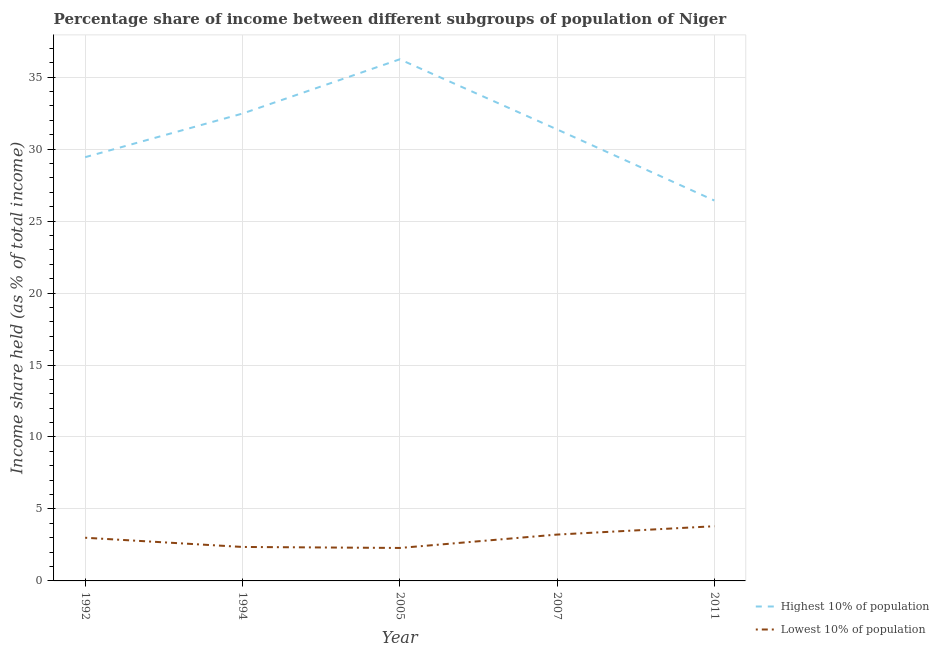Does the line corresponding to income share held by lowest 10% of the population intersect with the line corresponding to income share held by highest 10% of the population?
Your answer should be compact. No. Is the number of lines equal to the number of legend labels?
Your answer should be compact. Yes. What is the income share held by highest 10% of the population in 2005?
Your answer should be compact. 36.24. Across all years, what is the minimum income share held by lowest 10% of the population?
Your answer should be compact. 2.29. In which year was the income share held by lowest 10% of the population minimum?
Give a very brief answer. 2005. What is the total income share held by highest 10% of the population in the graph?
Provide a short and direct response. 155.95. What is the difference between the income share held by highest 10% of the population in 2007 and that in 2011?
Make the answer very short. 4.94. What is the difference between the income share held by highest 10% of the population in 2011 and the income share held by lowest 10% of the population in 2007?
Ensure brevity in your answer.  23.21. What is the average income share held by highest 10% of the population per year?
Provide a short and direct response. 31.19. In the year 2011, what is the difference between the income share held by lowest 10% of the population and income share held by highest 10% of the population?
Your answer should be compact. -22.63. In how many years, is the income share held by lowest 10% of the population greater than 29 %?
Provide a succinct answer. 0. What is the ratio of the income share held by lowest 10% of the population in 1994 to that in 2007?
Offer a terse response. 0.73. Is the income share held by highest 10% of the population in 1994 less than that in 2007?
Keep it short and to the point. No. What is the difference between the highest and the second highest income share held by highest 10% of the population?
Make the answer very short. 3.77. What is the difference between the highest and the lowest income share held by lowest 10% of the population?
Your response must be concise. 1.51. In how many years, is the income share held by highest 10% of the population greater than the average income share held by highest 10% of the population taken over all years?
Your answer should be compact. 3. Does the income share held by lowest 10% of the population monotonically increase over the years?
Give a very brief answer. No. Is the income share held by highest 10% of the population strictly greater than the income share held by lowest 10% of the population over the years?
Provide a succinct answer. Yes. How many lines are there?
Offer a very short reply. 2. How many years are there in the graph?
Ensure brevity in your answer.  5. What is the difference between two consecutive major ticks on the Y-axis?
Offer a very short reply. 5. Are the values on the major ticks of Y-axis written in scientific E-notation?
Your answer should be compact. No. Does the graph contain any zero values?
Provide a short and direct response. No. How many legend labels are there?
Your answer should be very brief. 2. How are the legend labels stacked?
Your answer should be compact. Vertical. What is the title of the graph?
Keep it short and to the point. Percentage share of income between different subgroups of population of Niger. Does "International Visitors" appear as one of the legend labels in the graph?
Give a very brief answer. No. What is the label or title of the X-axis?
Your response must be concise. Year. What is the label or title of the Y-axis?
Provide a short and direct response. Income share held (as % of total income). What is the Income share held (as % of total income) of Highest 10% of population in 1992?
Provide a short and direct response. 29.44. What is the Income share held (as % of total income) of Highest 10% of population in 1994?
Your answer should be very brief. 32.47. What is the Income share held (as % of total income) of Lowest 10% of population in 1994?
Offer a terse response. 2.36. What is the Income share held (as % of total income) in Highest 10% of population in 2005?
Offer a very short reply. 36.24. What is the Income share held (as % of total income) of Lowest 10% of population in 2005?
Offer a terse response. 2.29. What is the Income share held (as % of total income) of Highest 10% of population in 2007?
Provide a short and direct response. 31.37. What is the Income share held (as % of total income) in Lowest 10% of population in 2007?
Offer a terse response. 3.22. What is the Income share held (as % of total income) in Highest 10% of population in 2011?
Keep it short and to the point. 26.43. Across all years, what is the maximum Income share held (as % of total income) of Highest 10% of population?
Offer a very short reply. 36.24. Across all years, what is the minimum Income share held (as % of total income) in Highest 10% of population?
Offer a very short reply. 26.43. Across all years, what is the minimum Income share held (as % of total income) of Lowest 10% of population?
Make the answer very short. 2.29. What is the total Income share held (as % of total income) in Highest 10% of population in the graph?
Provide a short and direct response. 155.95. What is the total Income share held (as % of total income) in Lowest 10% of population in the graph?
Keep it short and to the point. 14.67. What is the difference between the Income share held (as % of total income) in Highest 10% of population in 1992 and that in 1994?
Ensure brevity in your answer.  -3.03. What is the difference between the Income share held (as % of total income) of Lowest 10% of population in 1992 and that in 1994?
Provide a short and direct response. 0.64. What is the difference between the Income share held (as % of total income) in Highest 10% of population in 1992 and that in 2005?
Your response must be concise. -6.8. What is the difference between the Income share held (as % of total income) of Lowest 10% of population in 1992 and that in 2005?
Your answer should be very brief. 0.71. What is the difference between the Income share held (as % of total income) of Highest 10% of population in 1992 and that in 2007?
Offer a terse response. -1.93. What is the difference between the Income share held (as % of total income) in Lowest 10% of population in 1992 and that in 2007?
Your answer should be very brief. -0.22. What is the difference between the Income share held (as % of total income) of Highest 10% of population in 1992 and that in 2011?
Keep it short and to the point. 3.01. What is the difference between the Income share held (as % of total income) in Lowest 10% of population in 1992 and that in 2011?
Give a very brief answer. -0.8. What is the difference between the Income share held (as % of total income) in Highest 10% of population in 1994 and that in 2005?
Provide a succinct answer. -3.77. What is the difference between the Income share held (as % of total income) of Lowest 10% of population in 1994 and that in 2005?
Provide a succinct answer. 0.07. What is the difference between the Income share held (as % of total income) of Lowest 10% of population in 1994 and that in 2007?
Your response must be concise. -0.86. What is the difference between the Income share held (as % of total income) in Highest 10% of population in 1994 and that in 2011?
Your answer should be very brief. 6.04. What is the difference between the Income share held (as % of total income) of Lowest 10% of population in 1994 and that in 2011?
Provide a succinct answer. -1.44. What is the difference between the Income share held (as % of total income) of Highest 10% of population in 2005 and that in 2007?
Provide a short and direct response. 4.87. What is the difference between the Income share held (as % of total income) in Lowest 10% of population in 2005 and that in 2007?
Give a very brief answer. -0.93. What is the difference between the Income share held (as % of total income) of Highest 10% of population in 2005 and that in 2011?
Your answer should be very brief. 9.81. What is the difference between the Income share held (as % of total income) in Lowest 10% of population in 2005 and that in 2011?
Offer a terse response. -1.51. What is the difference between the Income share held (as % of total income) in Highest 10% of population in 2007 and that in 2011?
Offer a very short reply. 4.94. What is the difference between the Income share held (as % of total income) in Lowest 10% of population in 2007 and that in 2011?
Your answer should be compact. -0.58. What is the difference between the Income share held (as % of total income) of Highest 10% of population in 1992 and the Income share held (as % of total income) of Lowest 10% of population in 1994?
Keep it short and to the point. 27.08. What is the difference between the Income share held (as % of total income) in Highest 10% of population in 1992 and the Income share held (as % of total income) in Lowest 10% of population in 2005?
Ensure brevity in your answer.  27.15. What is the difference between the Income share held (as % of total income) of Highest 10% of population in 1992 and the Income share held (as % of total income) of Lowest 10% of population in 2007?
Offer a terse response. 26.22. What is the difference between the Income share held (as % of total income) of Highest 10% of population in 1992 and the Income share held (as % of total income) of Lowest 10% of population in 2011?
Your answer should be compact. 25.64. What is the difference between the Income share held (as % of total income) of Highest 10% of population in 1994 and the Income share held (as % of total income) of Lowest 10% of population in 2005?
Provide a short and direct response. 30.18. What is the difference between the Income share held (as % of total income) of Highest 10% of population in 1994 and the Income share held (as % of total income) of Lowest 10% of population in 2007?
Your answer should be compact. 29.25. What is the difference between the Income share held (as % of total income) in Highest 10% of population in 1994 and the Income share held (as % of total income) in Lowest 10% of population in 2011?
Ensure brevity in your answer.  28.67. What is the difference between the Income share held (as % of total income) in Highest 10% of population in 2005 and the Income share held (as % of total income) in Lowest 10% of population in 2007?
Provide a succinct answer. 33.02. What is the difference between the Income share held (as % of total income) of Highest 10% of population in 2005 and the Income share held (as % of total income) of Lowest 10% of population in 2011?
Ensure brevity in your answer.  32.44. What is the difference between the Income share held (as % of total income) of Highest 10% of population in 2007 and the Income share held (as % of total income) of Lowest 10% of population in 2011?
Your response must be concise. 27.57. What is the average Income share held (as % of total income) in Highest 10% of population per year?
Keep it short and to the point. 31.19. What is the average Income share held (as % of total income) in Lowest 10% of population per year?
Give a very brief answer. 2.93. In the year 1992, what is the difference between the Income share held (as % of total income) of Highest 10% of population and Income share held (as % of total income) of Lowest 10% of population?
Keep it short and to the point. 26.44. In the year 1994, what is the difference between the Income share held (as % of total income) in Highest 10% of population and Income share held (as % of total income) in Lowest 10% of population?
Offer a terse response. 30.11. In the year 2005, what is the difference between the Income share held (as % of total income) in Highest 10% of population and Income share held (as % of total income) in Lowest 10% of population?
Provide a short and direct response. 33.95. In the year 2007, what is the difference between the Income share held (as % of total income) in Highest 10% of population and Income share held (as % of total income) in Lowest 10% of population?
Your answer should be compact. 28.15. In the year 2011, what is the difference between the Income share held (as % of total income) of Highest 10% of population and Income share held (as % of total income) of Lowest 10% of population?
Keep it short and to the point. 22.63. What is the ratio of the Income share held (as % of total income) of Highest 10% of population in 1992 to that in 1994?
Provide a succinct answer. 0.91. What is the ratio of the Income share held (as % of total income) in Lowest 10% of population in 1992 to that in 1994?
Your answer should be very brief. 1.27. What is the ratio of the Income share held (as % of total income) of Highest 10% of population in 1992 to that in 2005?
Offer a very short reply. 0.81. What is the ratio of the Income share held (as % of total income) of Lowest 10% of population in 1992 to that in 2005?
Your answer should be very brief. 1.31. What is the ratio of the Income share held (as % of total income) of Highest 10% of population in 1992 to that in 2007?
Your answer should be very brief. 0.94. What is the ratio of the Income share held (as % of total income) in Lowest 10% of population in 1992 to that in 2007?
Give a very brief answer. 0.93. What is the ratio of the Income share held (as % of total income) in Highest 10% of population in 1992 to that in 2011?
Offer a terse response. 1.11. What is the ratio of the Income share held (as % of total income) of Lowest 10% of population in 1992 to that in 2011?
Your answer should be very brief. 0.79. What is the ratio of the Income share held (as % of total income) in Highest 10% of population in 1994 to that in 2005?
Your response must be concise. 0.9. What is the ratio of the Income share held (as % of total income) in Lowest 10% of population in 1994 to that in 2005?
Ensure brevity in your answer.  1.03. What is the ratio of the Income share held (as % of total income) in Highest 10% of population in 1994 to that in 2007?
Offer a very short reply. 1.04. What is the ratio of the Income share held (as % of total income) of Lowest 10% of population in 1994 to that in 2007?
Ensure brevity in your answer.  0.73. What is the ratio of the Income share held (as % of total income) of Highest 10% of population in 1994 to that in 2011?
Keep it short and to the point. 1.23. What is the ratio of the Income share held (as % of total income) in Lowest 10% of population in 1994 to that in 2011?
Provide a short and direct response. 0.62. What is the ratio of the Income share held (as % of total income) of Highest 10% of population in 2005 to that in 2007?
Your answer should be compact. 1.16. What is the ratio of the Income share held (as % of total income) in Lowest 10% of population in 2005 to that in 2007?
Keep it short and to the point. 0.71. What is the ratio of the Income share held (as % of total income) of Highest 10% of population in 2005 to that in 2011?
Your answer should be compact. 1.37. What is the ratio of the Income share held (as % of total income) in Lowest 10% of population in 2005 to that in 2011?
Your answer should be very brief. 0.6. What is the ratio of the Income share held (as % of total income) of Highest 10% of population in 2007 to that in 2011?
Provide a succinct answer. 1.19. What is the ratio of the Income share held (as % of total income) of Lowest 10% of population in 2007 to that in 2011?
Your response must be concise. 0.85. What is the difference between the highest and the second highest Income share held (as % of total income) in Highest 10% of population?
Keep it short and to the point. 3.77. What is the difference between the highest and the second highest Income share held (as % of total income) of Lowest 10% of population?
Provide a succinct answer. 0.58. What is the difference between the highest and the lowest Income share held (as % of total income) of Highest 10% of population?
Offer a very short reply. 9.81. What is the difference between the highest and the lowest Income share held (as % of total income) of Lowest 10% of population?
Your answer should be very brief. 1.51. 